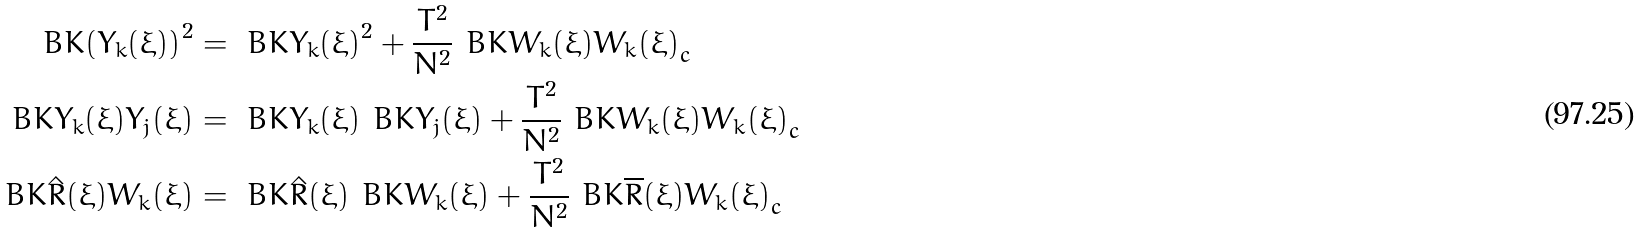<formula> <loc_0><loc_0><loc_500><loc_500>\ B K { \left ( Y _ { k } ( \xi ) \right ) ^ { 2 } } & = \ B K { Y _ { k } ( \xi ) } ^ { 2 } + { \frac { T ^ { 2 } } { N ^ { 2 } } } \ B K { W _ { k } ( \xi ) W _ { k } ( \xi ) } _ { c } \\ \ B K { Y _ { k } ( \xi ) { Y } _ { j } ( \xi ) } & = \ B K { Y _ { k } ( \xi ) } \ B K { { Y } _ { j } ( \xi ) } + \frac { T ^ { 2 } } { N ^ { 2 } } \ B K { W _ { k } ( \xi ) W _ { k } ( \xi ) } _ { c } \\ \ B K { \hat { R } ( \xi ) W _ { k } ( \xi ) } & = \ B K { \hat { R } ( \xi ) } \ B K { W _ { k } ( \xi ) } + \frac { T ^ { 2 } } { N ^ { 2 } } \ B K { \overline { R } ( \xi ) W _ { k } ( \xi ) } _ { c }</formula> 